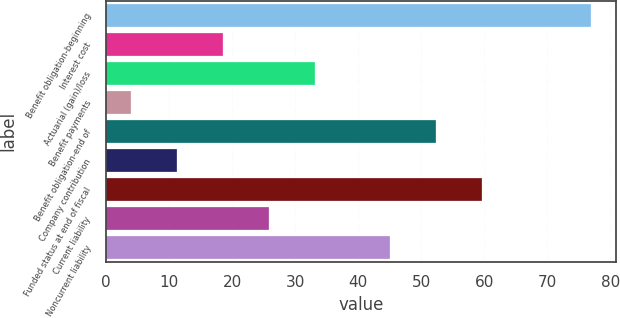<chart> <loc_0><loc_0><loc_500><loc_500><bar_chart><fcel>Benefit obligation-beginning<fcel>Interest cost<fcel>Actuarial (gain)/loss<fcel>Benefit payments<fcel>Benefit obligation-end of<fcel>Company contribution<fcel>Funded status at end of fiscal<fcel>Current liability<fcel>Noncurrent liability<nl><fcel>77<fcel>18.6<fcel>33.2<fcel>4<fcel>52.3<fcel>11.3<fcel>59.6<fcel>25.9<fcel>45<nl></chart> 